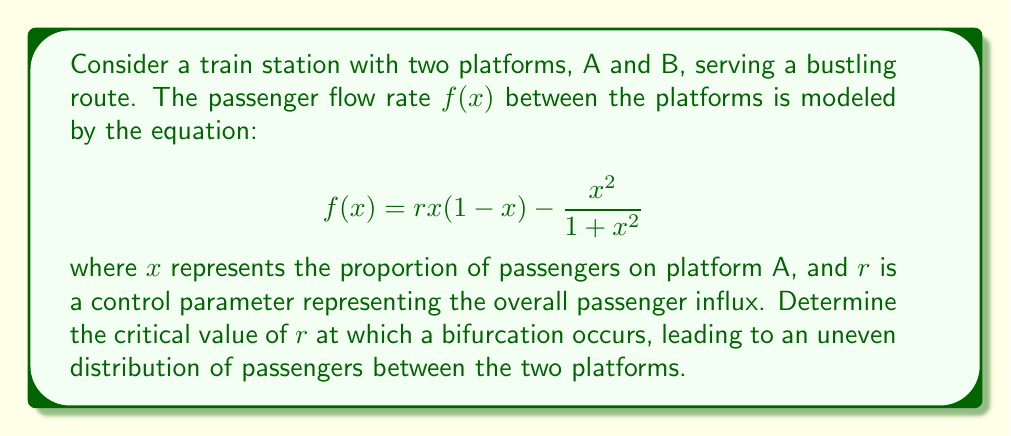Give your solution to this math problem. To solve this problem, we'll follow these steps:

1) First, we need to find the equilibrium points of the system. These occur when $f(x) = 0$.

2) The trivial equilibrium point is always $x = 0$. We're interested in non-trivial equilibrium points.

3) For non-trivial equilibrium points, we have:

   $$rx(1-x) - \frac{x^2}{1+x^2} = 0$$

4) Rearranging this equation:

   $$rx - rx^2 = \frac{x^2}{1+x^2}$$

5) Multiply both sides by $(1+x^2)$:

   $$rx(1+x^2) - rx^2(1+x^2) = x^2$$

6) Expand:

   $$rx + rx^3 - rx^2 - rx^4 = x^2$$

7) Rearrange:

   $$rx^4 + (r-1)x^2 - rx = 0$$

8) This is a cubic equation in $x^2$. A bifurcation occurs when this equation transitions from having one real root to three real roots.

9) This transition happens when the discriminant of the cubic equation is zero. For a cubic equation $ax^3 + bx^2 + cx + d = 0$, the discriminant is:

   $$\Delta = 18abcd - 4b^3d + b^2c^2 - 4ac^3 - 27a^2d^2$$

10) In our case, let $y = x^2$. Then our equation becomes:

    $$ry^2 + (r-1)y - rx = 0$$

11) Comparing with the standard form, we have:
    $a = r$, $b = r-1$, $c = -r$, $d = 0$

12) Substituting into the discriminant formula:

    $$\Delta = 18r(r-1)(-r)(0) - 4(r-1)^3(0) + (r-1)^2(-r)^2 - 4r(-r)^3 - 27r^2(0)^2$$

13) Simplifying:

    $$\Delta = (r-1)^2r^2 + 4r^4 = r^2((r-1)^2 + 4r^2)$$

14) The bifurcation occurs when $\Delta = 0$. Solving:

    $$r^2((r-1)^2 + 4r^2) = 0$$

15) The non-trivial solution is:

    $$(r-1)^2 + 4r^2 = 0$$
    $$r^2 - 2r + 1 + 4r^2 = 0$$
    $$5r^2 - 2r + 1 = 0$$

16) Solving this quadratic equation:

    $$r = \frac{2 \pm \sqrt{4 - 20}}{10} = \frac{2 \pm \sqrt{-16}}{10} = \frac{1 \pm 2i}{5}$$

17) Since $r$ represents a real parameter, we take the real part of this complex solution.
Answer: $r_c = \frac{1}{5} = 0.2$ 